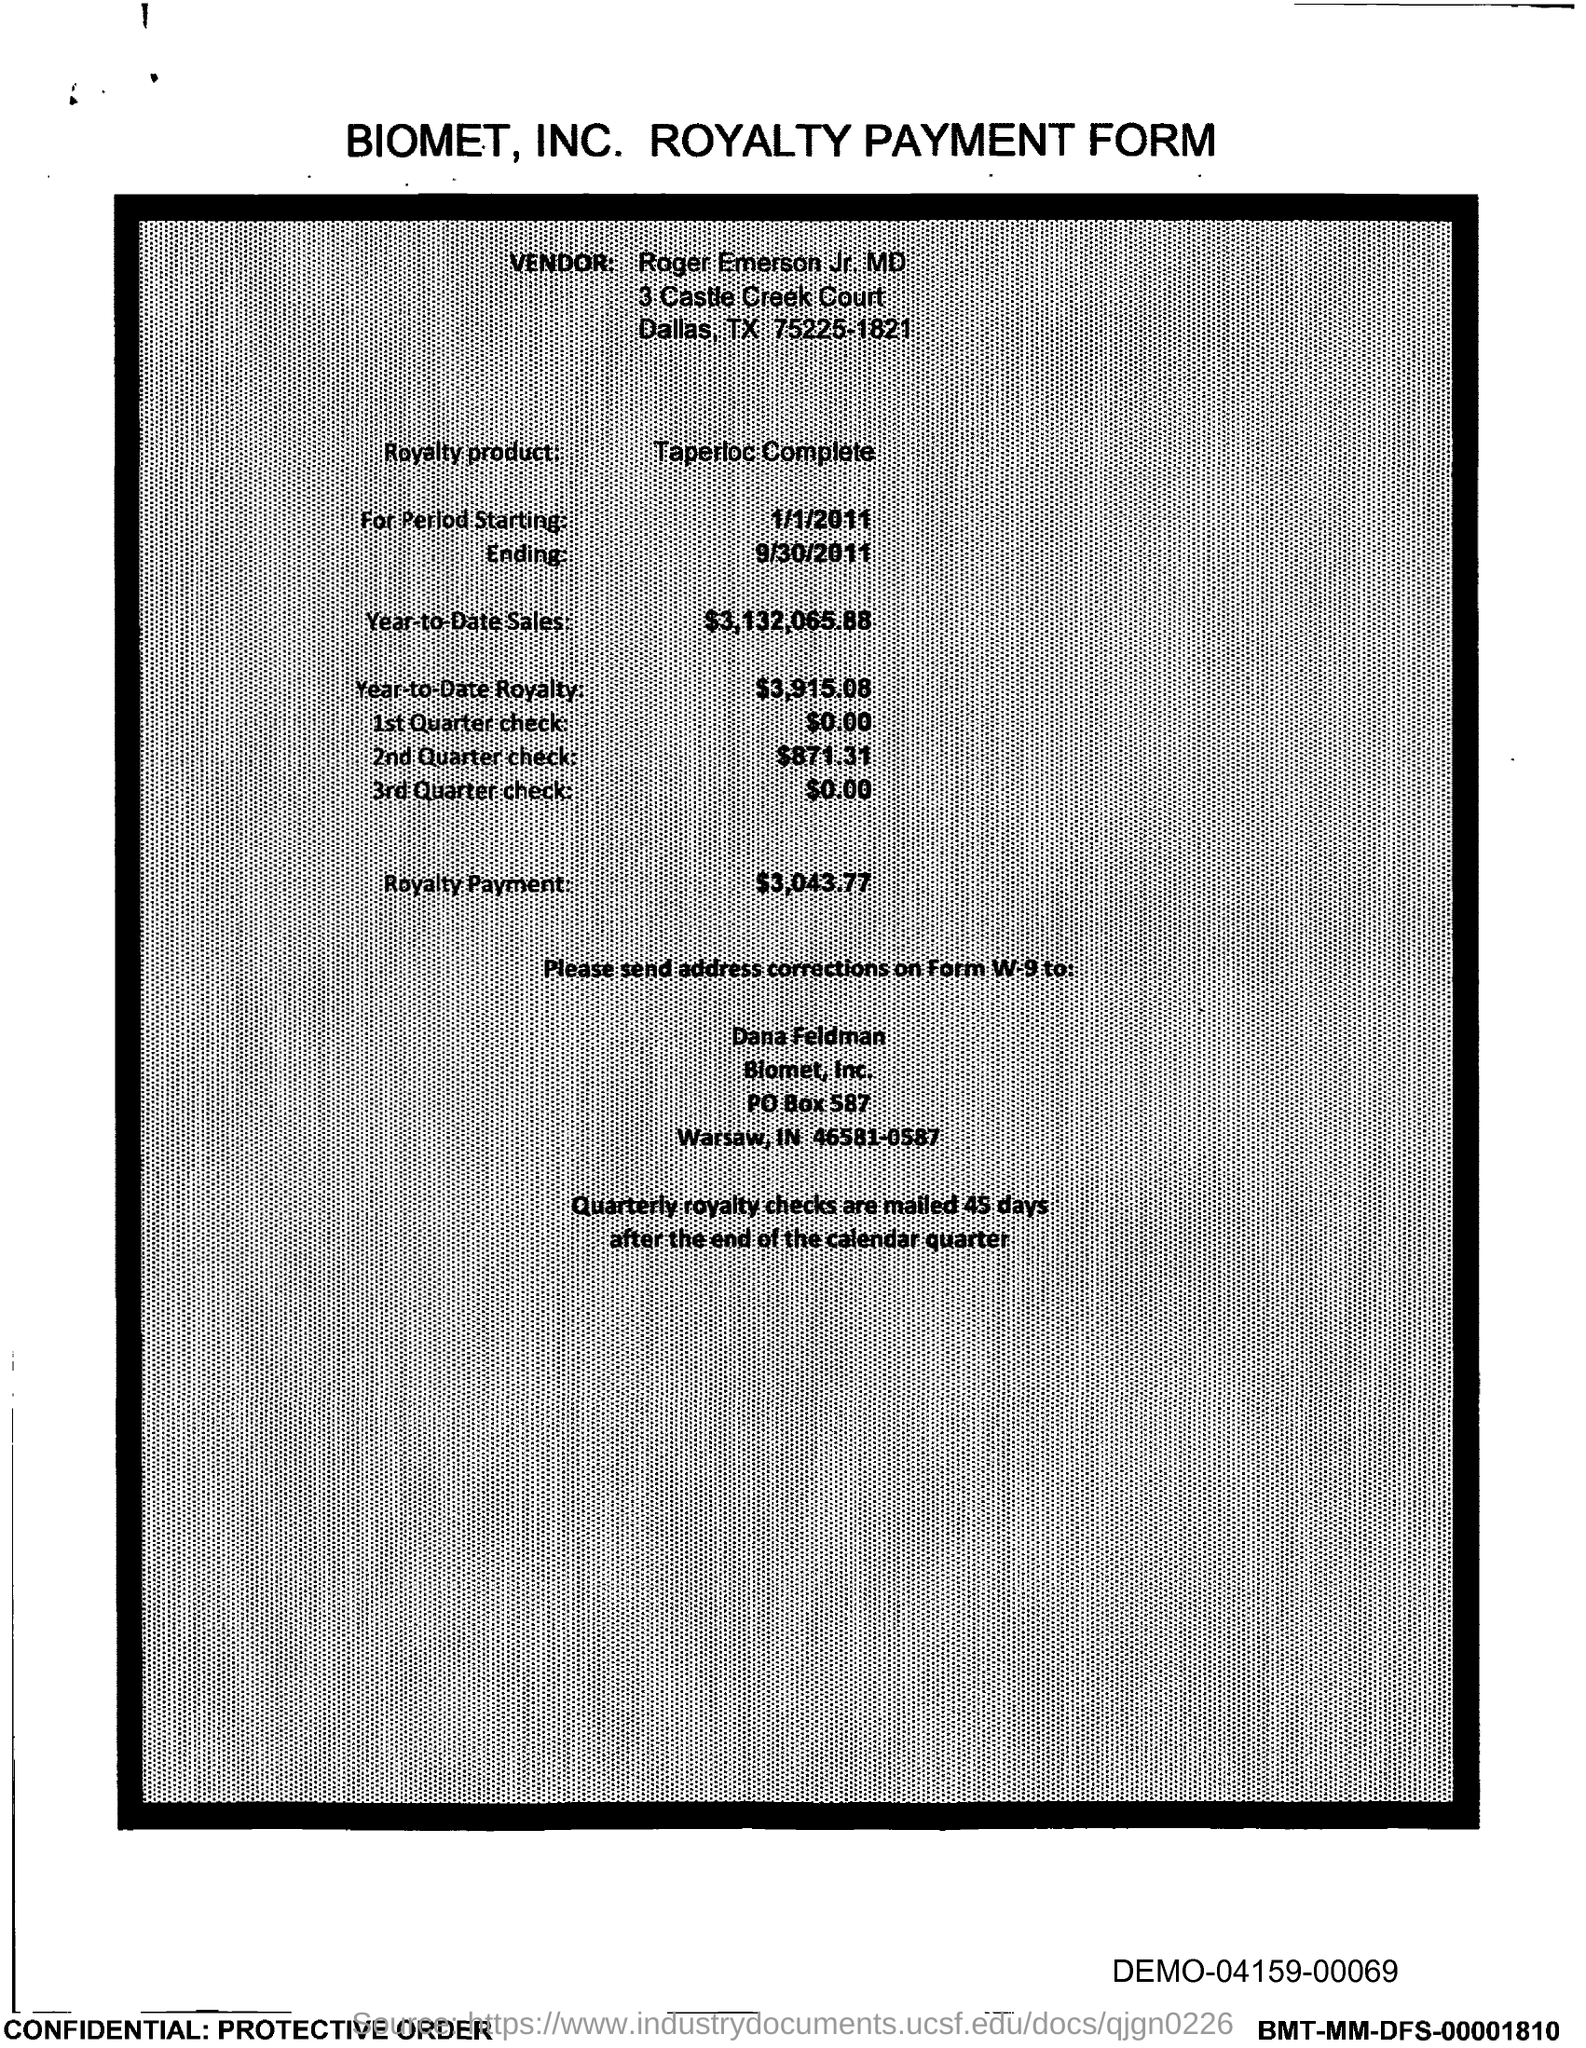What is the PO Box Number mentioned in the document?
Keep it short and to the point. 587. 